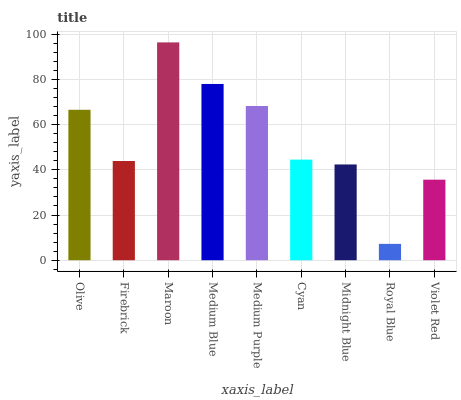Is Royal Blue the minimum?
Answer yes or no. Yes. Is Maroon the maximum?
Answer yes or no. Yes. Is Firebrick the minimum?
Answer yes or no. No. Is Firebrick the maximum?
Answer yes or no. No. Is Olive greater than Firebrick?
Answer yes or no. Yes. Is Firebrick less than Olive?
Answer yes or no. Yes. Is Firebrick greater than Olive?
Answer yes or no. No. Is Olive less than Firebrick?
Answer yes or no. No. Is Cyan the high median?
Answer yes or no. Yes. Is Cyan the low median?
Answer yes or no. Yes. Is Violet Red the high median?
Answer yes or no. No. Is Medium Blue the low median?
Answer yes or no. No. 